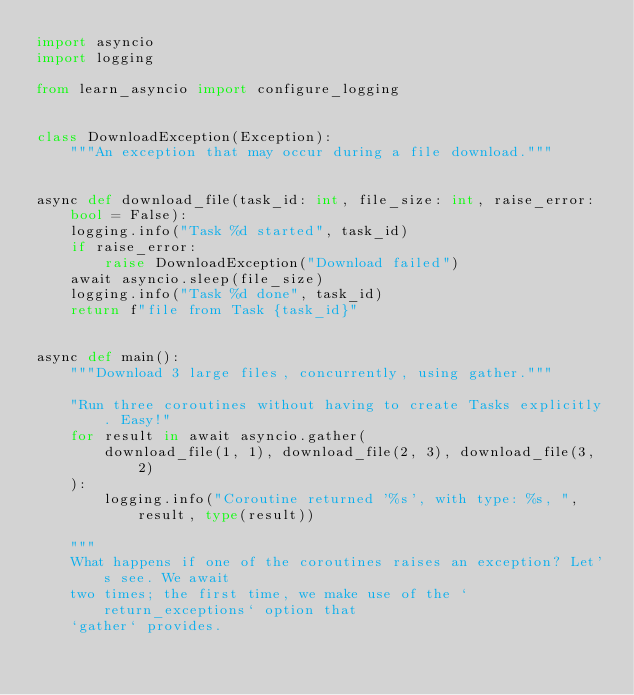<code> <loc_0><loc_0><loc_500><loc_500><_Python_>import asyncio
import logging

from learn_asyncio import configure_logging


class DownloadException(Exception):
    """An exception that may occur during a file download."""


async def download_file(task_id: int, file_size: int, raise_error: bool = False):
    logging.info("Task %d started", task_id)
    if raise_error:
        raise DownloadException("Download failed")
    await asyncio.sleep(file_size)
    logging.info("Task %d done", task_id)
    return f"file from Task {task_id}"


async def main():
    """Download 3 large files, concurrently, using gather."""

    "Run three coroutines without having to create Tasks explicitly. Easy!"
    for result in await asyncio.gather(
        download_file(1, 1), download_file(2, 3), download_file(3, 2)
    ):
        logging.info("Coroutine returned '%s', with type: %s, ", result, type(result))

    """
    What happens if one of the coroutines raises an exception? Let's see. We await 
    two times; the first time, we make use of the `return_exceptions` option that 
    `gather` provides.
    </code> 